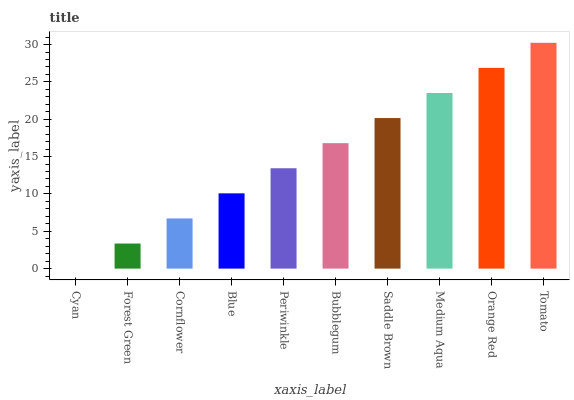Is Cyan the minimum?
Answer yes or no. Yes. Is Tomato the maximum?
Answer yes or no. Yes. Is Forest Green the minimum?
Answer yes or no. No. Is Forest Green the maximum?
Answer yes or no. No. Is Forest Green greater than Cyan?
Answer yes or no. Yes. Is Cyan less than Forest Green?
Answer yes or no. Yes. Is Cyan greater than Forest Green?
Answer yes or no. No. Is Forest Green less than Cyan?
Answer yes or no. No. Is Bubblegum the high median?
Answer yes or no. Yes. Is Periwinkle the low median?
Answer yes or no. Yes. Is Medium Aqua the high median?
Answer yes or no. No. Is Cyan the low median?
Answer yes or no. No. 